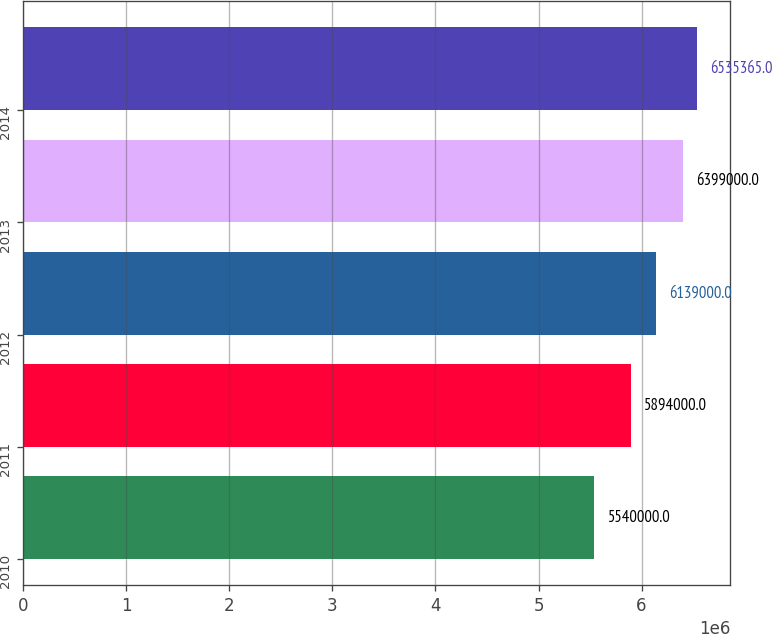Convert chart. <chart><loc_0><loc_0><loc_500><loc_500><bar_chart><fcel>2010<fcel>2011<fcel>2012<fcel>2013<fcel>2014<nl><fcel>5.54e+06<fcel>5.894e+06<fcel>6.139e+06<fcel>6.399e+06<fcel>6.53536e+06<nl></chart> 